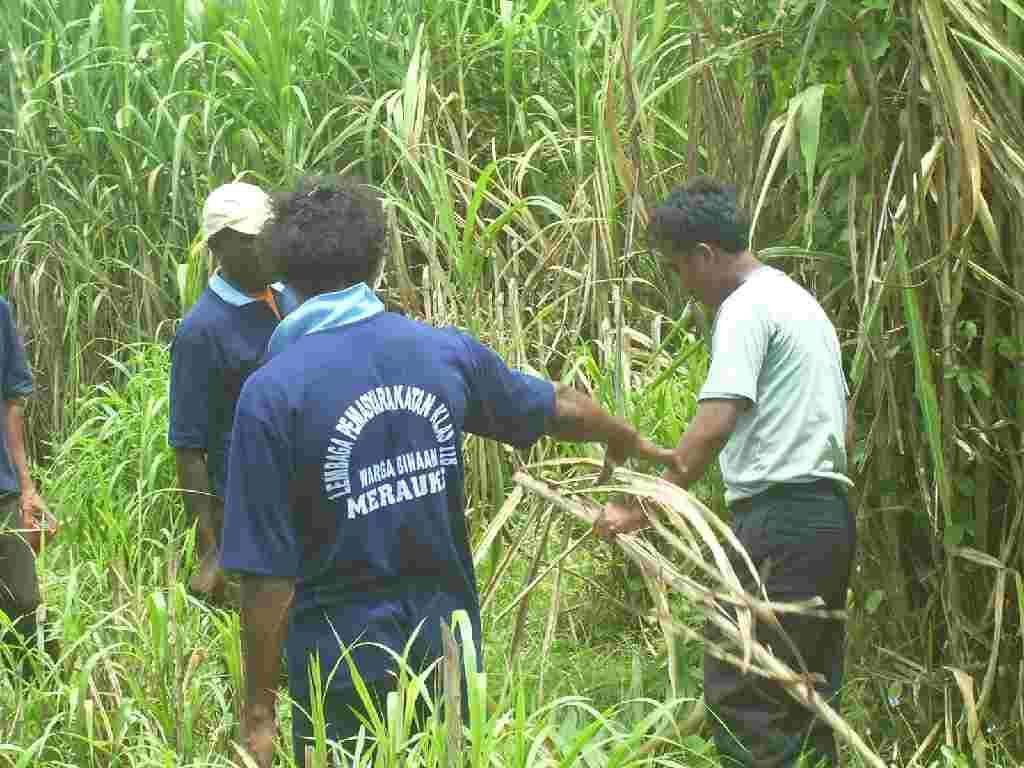What is happening in the field in the image? There are people standing in the field. Can you describe what one of the people is doing? There is a person holding a plant in his hands. What type of bread can be seen in the hands of the person holding the plant? There is no bread present in the image; the person is holding a plant. Can you hear any bells ringing in the image? There is no mention of bells in the image, so it cannot be determined if they are present or ringing. 